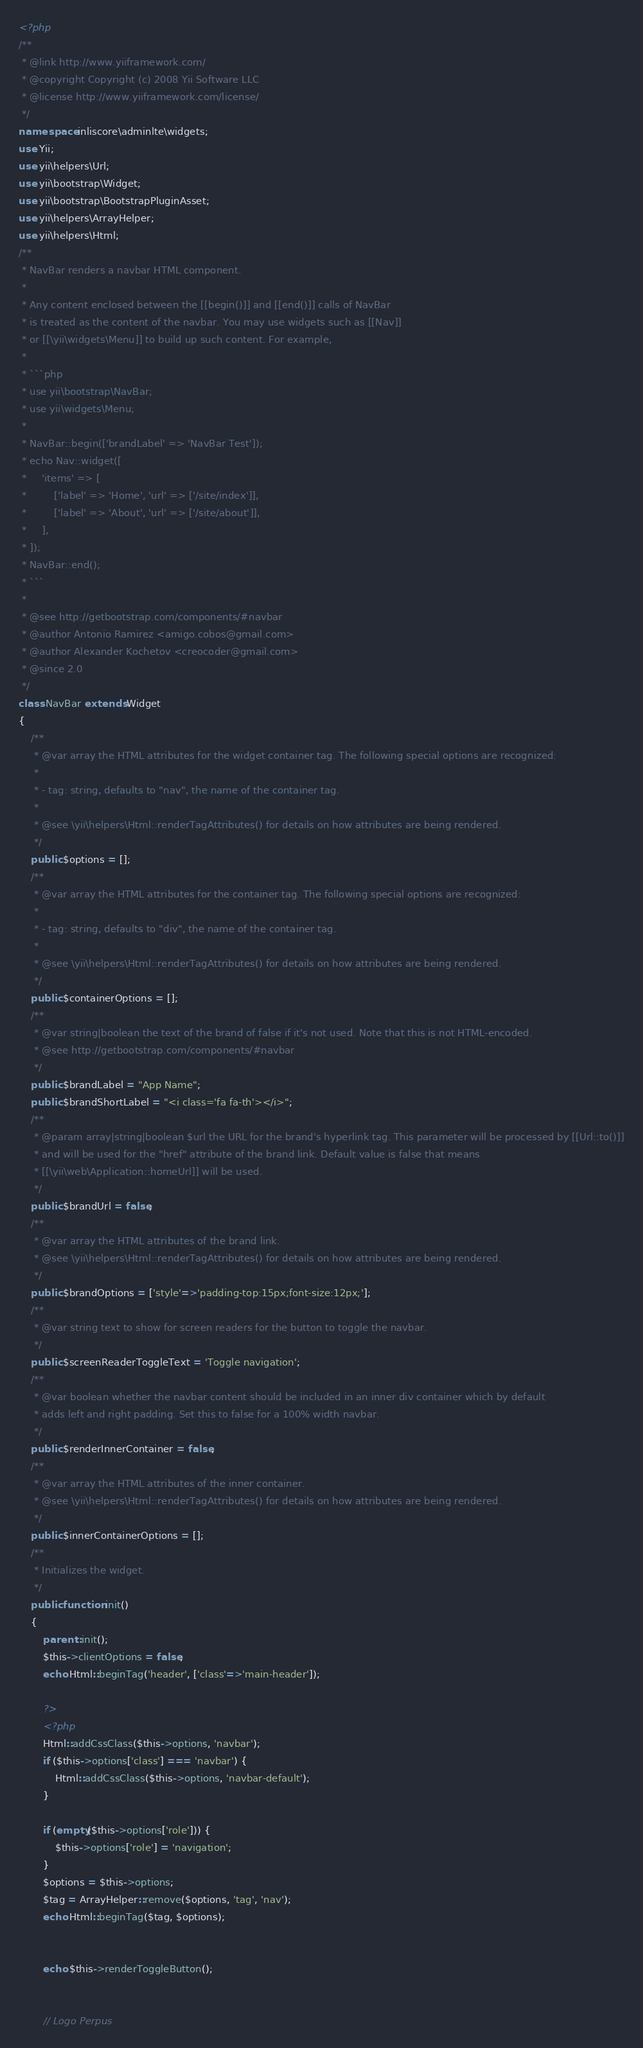Convert code to text. <code><loc_0><loc_0><loc_500><loc_500><_PHP_><?php
/**
 * @link http://www.yiiframework.com/
 * @copyright Copyright (c) 2008 Yii Software LLC
 * @license http://www.yiiframework.com/license/
 */
namespace inliscore\adminlte\widgets;
use Yii;
use yii\helpers\Url;
use yii\bootstrap\Widget;
use yii\bootstrap\BootstrapPluginAsset;
use yii\helpers\ArrayHelper;
use yii\helpers\Html;
/**
 * NavBar renders a navbar HTML component.
 *
 * Any content enclosed between the [[begin()]] and [[end()]] calls of NavBar
 * is treated as the content of the navbar. You may use widgets such as [[Nav]]
 * or [[\yii\widgets\Menu]] to build up such content. For example,
 *
 * ```php
 * use yii\bootstrap\NavBar;
 * use yii\widgets\Menu;
 *
 * NavBar::begin(['brandLabel' => 'NavBar Test']);
 * echo Nav::widget([
 *     'items' => [
 *         ['label' => 'Home', 'url' => ['/site/index']],
 *         ['label' => 'About', 'url' => ['/site/about']],
 *     ],
 * ]);
 * NavBar::end();
 * ```
 *
 * @see http://getbootstrap.com/components/#navbar
 * @author Antonio Ramirez <amigo.cobos@gmail.com>
 * @author Alexander Kochetov <creocoder@gmail.com>
 * @since 2.0
 */
class NavBar extends Widget
{
    /**
     * @var array the HTML attributes for the widget container tag. The following special options are recognized:
     *
     * - tag: string, defaults to "nav", the name of the container tag.
     *
     * @see \yii\helpers\Html::renderTagAttributes() for details on how attributes are being rendered.
     */
    public $options = [];
    /**
     * @var array the HTML attributes for the container tag. The following special options are recognized:
     *
     * - tag: string, defaults to "div", the name of the container tag.
     *
     * @see \yii\helpers\Html::renderTagAttributes() for details on how attributes are being rendered.
     */
    public $containerOptions = [];
    /**
     * @var string|boolean the text of the brand of false if it's not used. Note that this is not HTML-encoded.
     * @see http://getbootstrap.com/components/#navbar
     */
    public $brandLabel = "App Name";
    public $brandShortLabel = "<i class='fa fa-th'></i>";
    /**
     * @param array|string|boolean $url the URL for the brand's hyperlink tag. This parameter will be processed by [[Url::to()]]
     * and will be used for the "href" attribute of the brand link. Default value is false that means
     * [[\yii\web\Application::homeUrl]] will be used.
     */
    public $brandUrl = false;
    /**
     * @var array the HTML attributes of the brand link.
     * @see \yii\helpers\Html::renderTagAttributes() for details on how attributes are being rendered.
     */
    public $brandOptions = ['style'=>'padding-top:15px;font-size:12px;'];
    /**
     * @var string text to show for screen readers for the button to toggle the navbar.
     */
    public $screenReaderToggleText = 'Toggle navigation';
    /**
     * @var boolean whether the navbar content should be included in an inner div container which by default
     * adds left and right padding. Set this to false for a 100% width navbar.
     */
    public $renderInnerContainer = false;
    /**
     * @var array the HTML attributes of the inner container.
     * @see \yii\helpers\Html::renderTagAttributes() for details on how attributes are being rendered.
     */
    public $innerContainerOptions = [];
    /**
     * Initializes the widget.
     */
    public function init()
    {
        parent::init();
        $this->clientOptions = false;
        echo Html::beginTag('header', ['class'=>'main-header']);
        
        ?>
        <?php
        Html::addCssClass($this->options, 'navbar');
        if ($this->options['class'] === 'navbar') {
            Html::addCssClass($this->options, 'navbar-default');
        }
        
        if (empty($this->options['role'])) {
            $this->options['role'] = 'navigation';
        }
        $options = $this->options;
        $tag = ArrayHelper::remove($options, 'tag', 'nav');
        echo Html::beginTag($tag, $options);


        echo $this->renderToggleButton();


        // Logo Perpus</code> 